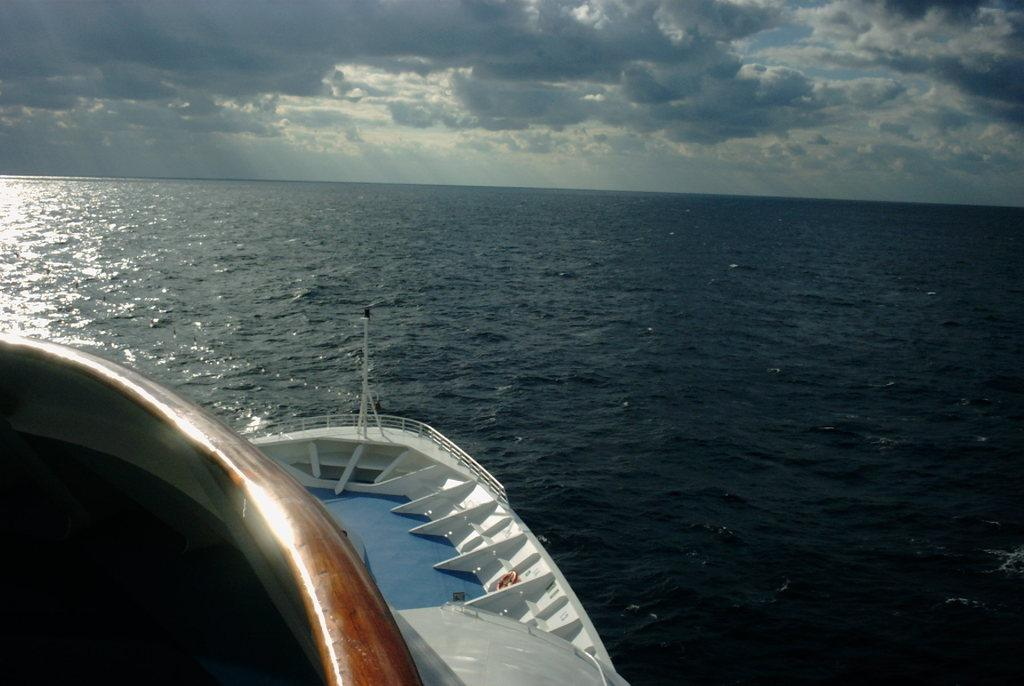What is the main subject in the foreground of the image? There is a ship in the foreground of the image. What is the ship situated on? The ship is on a water body, possibly an ocean. What can be seen in the background of the image? The sky is visible in the image. How would you describe the weather based on the sky's appearance? The sky is partially cloudy in the image. Where is the chain attached to in the image? There is no chain present in the image. What event is taking place in the room depicted in the image? There is no room depicted in the image; it features a ship on a water body with a partially cloudy sky. 